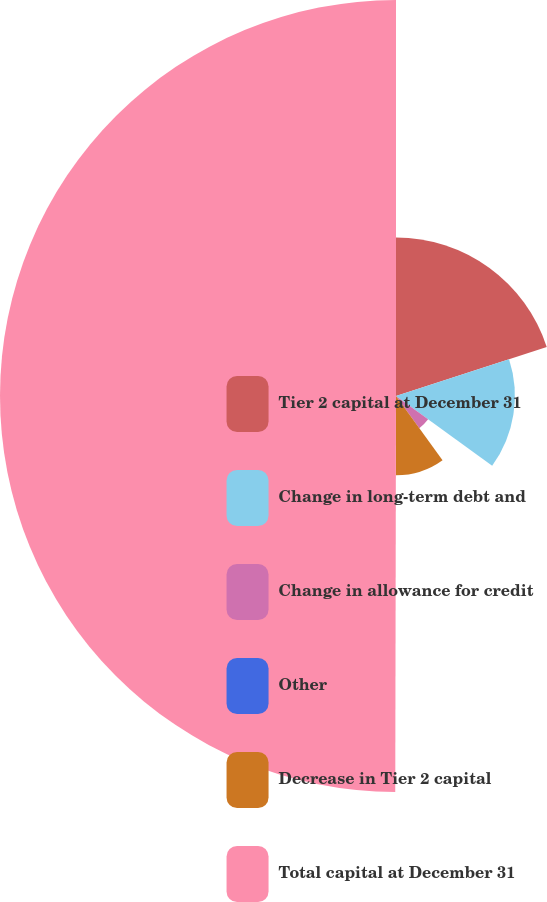<chart> <loc_0><loc_0><loc_500><loc_500><pie_chart><fcel>Tier 2 capital at December 31<fcel>Change in long-term debt and<fcel>Change in allowance for credit<fcel>Other<fcel>Decrease in Tier 2 capital<fcel>Total capital at December 31<nl><fcel>20.0%<fcel>15.0%<fcel>5.01%<fcel>0.01%<fcel>10.01%<fcel>49.97%<nl></chart> 